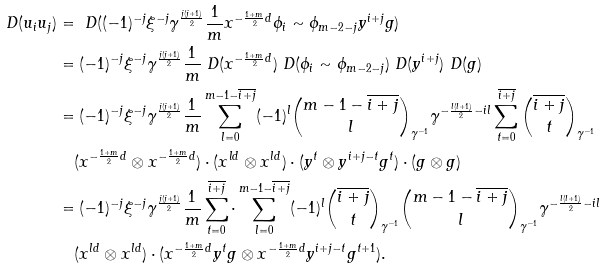Convert formula to latex. <formula><loc_0><loc_0><loc_500><loc_500>\ D ( u _ { i } u _ { j } ) & = \ D ( ( - 1 ) ^ { - j } \xi ^ { - j } \gamma ^ { \frac { j ( j + 1 ) } { 2 } } \frac { 1 } { m } x ^ { - \frac { 1 + m } { 2 } d } \phi _ { i } \sim \phi _ { m - 2 - j } y ^ { i + j } g ) \\ & = ( - 1 ) ^ { - j } \xi ^ { - j } \gamma ^ { \frac { j ( j + 1 ) } { 2 } } \frac { 1 } { m } \ D ( x ^ { - \frac { 1 + m } { 2 } d } ) \ D ( \phi _ { i } \sim \phi _ { m - 2 - j } ) \ D ( y ^ { i + j } ) \ D ( g ) \\ & = ( - 1 ) ^ { - j } \xi ^ { - j } \gamma ^ { \frac { j ( j + 1 ) } { 2 } } \frac { 1 } { m } \sum _ { l = 0 } ^ { m - 1 - \overline { i + j } } ( - 1 ) ^ { l } \binom { m - 1 - \overline { i + j } } { l } _ { \gamma ^ { - 1 } } \gamma ^ { - \frac { l ( l + 1 ) } { 2 } - i l } \sum _ { t = 0 } ^ { \overline { i + j } } \binom { \overline { i + j } } { t } _ { \gamma ^ { - 1 } } \\ & \quad ( x ^ { - \frac { 1 + m } { 2 } d } \otimes x ^ { - \frac { 1 + m } { 2 } d } ) \cdot ( x ^ { l d } \otimes x ^ { l d } ) \cdot ( y ^ { t } \otimes y ^ { i + j - t } g ^ { t } ) \cdot ( g \otimes g ) \\ & = ( - 1 ) ^ { - j } \xi ^ { - j } \gamma ^ { \frac { j ( j + 1 ) } { 2 } } \frac { 1 } { m } \sum _ { t = 0 } ^ { \overline { i + j } } \cdot \sum _ { l = 0 } ^ { m - 1 - \overline { i + j } } ( - 1 ) ^ { l } \binom { \overline { i + j } } { t } _ { \gamma ^ { - 1 } } \binom { m - 1 - \overline { i + j } } { l } _ { \gamma ^ { - 1 } } \gamma ^ { - \frac { l ( l + 1 ) } { 2 } - i l } \\ & \quad ( x ^ { l d } \otimes x ^ { l d } ) \cdot ( x ^ { - \frac { 1 + m } { 2 } d } y ^ { t } g \otimes x ^ { - \frac { 1 + m } { 2 } d } y ^ { i + j - t } g ^ { t + 1 } ) .</formula> 